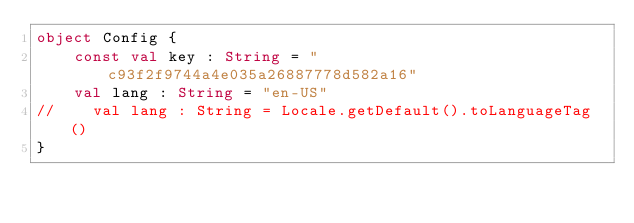<code> <loc_0><loc_0><loc_500><loc_500><_Kotlin_>object Config {
    const val key : String = "c93f2f9744a4e035a26887778d582a16"
    val lang : String = "en-US"
//    val lang : String = Locale.getDefault().toLanguageTag()
}</code> 